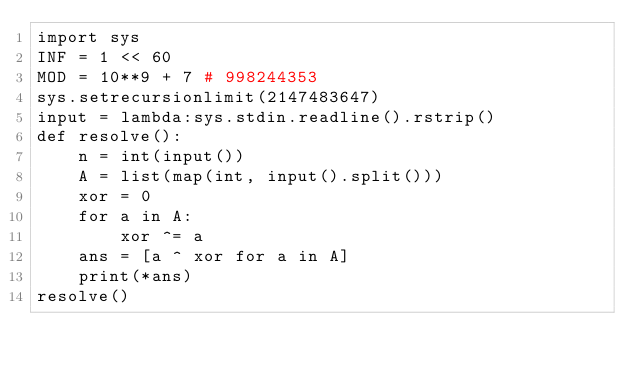Convert code to text. <code><loc_0><loc_0><loc_500><loc_500><_Python_>import sys
INF = 1 << 60
MOD = 10**9 + 7 # 998244353
sys.setrecursionlimit(2147483647)
input = lambda:sys.stdin.readline().rstrip()
def resolve():
    n = int(input())
    A = list(map(int, input().split()))
    xor = 0
    for a in A:
        xor ^= a
    ans = [a ^ xor for a in A]
    print(*ans)
resolve()</code> 